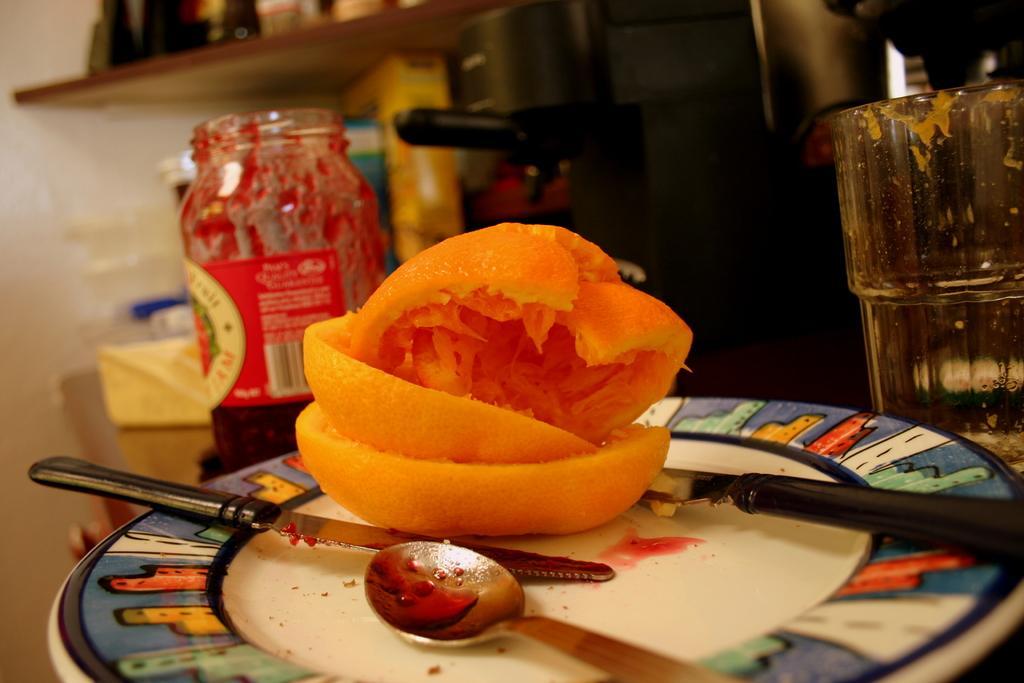Please provide a concise description of this image. In this image, we can see a plate contains spoon, knives and orange peel. There is glass on the right side of the image. There is a bottle in the middle of the image. There is a shelf in the top left of the image. 